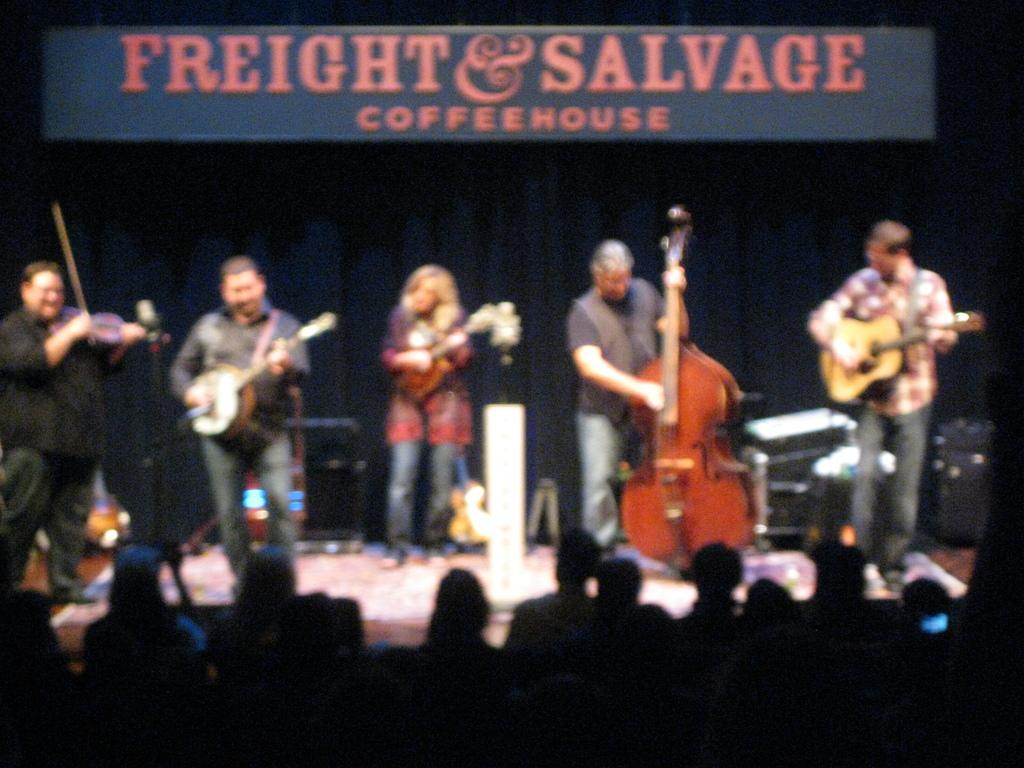What are the people in the image doing? The people in the image are standing and holding musical instruments. Are there any other positions that the people are in? Yes, there are people sitting in the image. What is the fifth person in the image doing? There is no mention of a fifth person in the image, so we cannot answer this question. 